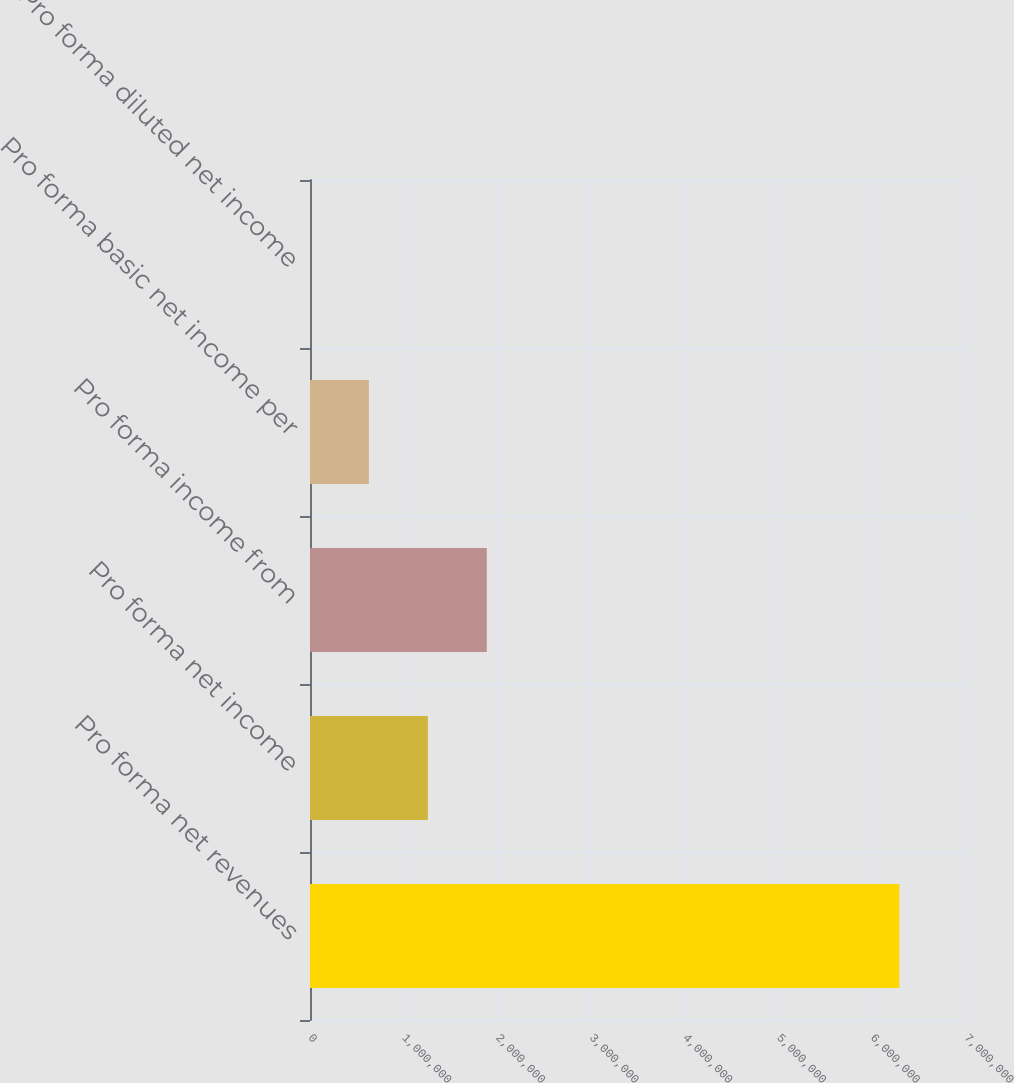Convert chart to OTSL. <chart><loc_0><loc_0><loc_500><loc_500><bar_chart><fcel>Pro forma net revenues<fcel>Pro forma net income<fcel>Pro forma income from<fcel>Pro forma basic net income per<fcel>Pro forma diluted net income<nl><fcel>6.28822e+06<fcel>1.25765e+06<fcel>1.88647e+06<fcel>628825<fcel>4.19<nl></chart> 